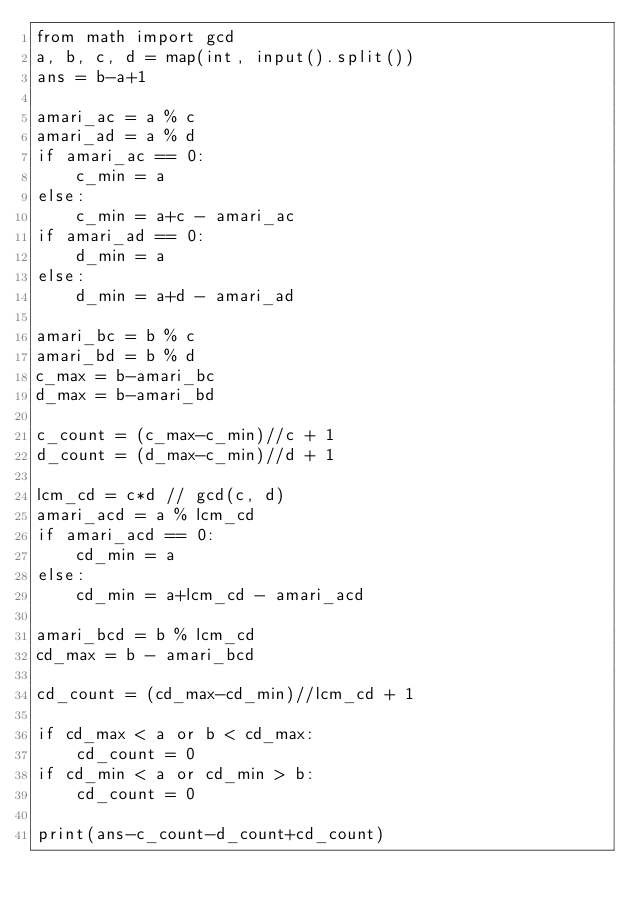Convert code to text. <code><loc_0><loc_0><loc_500><loc_500><_Python_>from math import gcd
a, b, c, d = map(int, input().split())
ans = b-a+1

amari_ac = a % c
amari_ad = a % d
if amari_ac == 0:
    c_min = a
else:
    c_min = a+c - amari_ac
if amari_ad == 0:
    d_min = a
else:
    d_min = a+d - amari_ad

amari_bc = b % c
amari_bd = b % d
c_max = b-amari_bc
d_max = b-amari_bd

c_count = (c_max-c_min)//c + 1
d_count = (d_max-c_min)//d + 1

lcm_cd = c*d // gcd(c, d)
amari_acd = a % lcm_cd
if amari_acd == 0:
    cd_min = a
else:
    cd_min = a+lcm_cd - amari_acd

amari_bcd = b % lcm_cd
cd_max = b - amari_bcd

cd_count = (cd_max-cd_min)//lcm_cd + 1

if cd_max < a or b < cd_max:
    cd_count = 0
if cd_min < a or cd_min > b:
    cd_count = 0

print(ans-c_count-d_count+cd_count)
</code> 